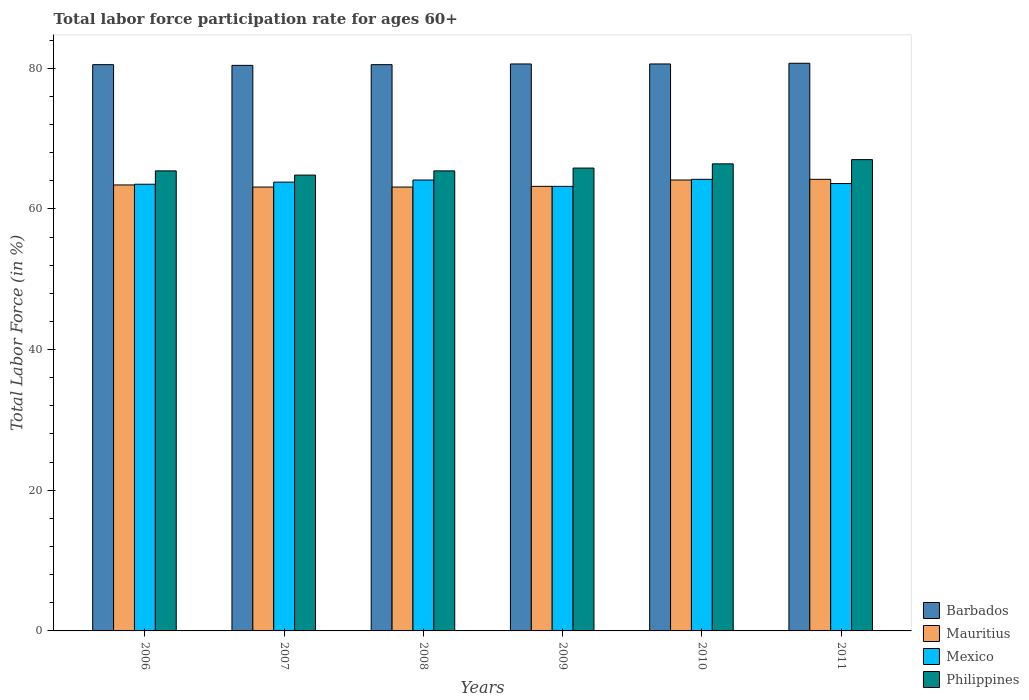How many different coloured bars are there?
Your answer should be very brief. 4. Are the number of bars per tick equal to the number of legend labels?
Your response must be concise. Yes. How many bars are there on the 4th tick from the left?
Offer a very short reply. 4. What is the label of the 4th group of bars from the left?
Provide a short and direct response. 2009. What is the labor force participation rate in Barbados in 2011?
Provide a succinct answer. 80.7. Across all years, what is the maximum labor force participation rate in Mauritius?
Provide a succinct answer. 64.2. Across all years, what is the minimum labor force participation rate in Mexico?
Your answer should be compact. 63.2. In which year was the labor force participation rate in Mexico maximum?
Provide a short and direct response. 2010. In which year was the labor force participation rate in Mexico minimum?
Your answer should be compact. 2009. What is the total labor force participation rate in Mexico in the graph?
Provide a succinct answer. 382.4. What is the difference between the labor force participation rate in Mauritius in 2009 and that in 2011?
Keep it short and to the point. -1. What is the difference between the labor force participation rate in Barbados in 2008 and the labor force participation rate in Mexico in 2006?
Provide a succinct answer. 17. What is the average labor force participation rate in Philippines per year?
Your answer should be compact. 65.8. In the year 2007, what is the difference between the labor force participation rate in Mauritius and labor force participation rate in Philippines?
Give a very brief answer. -1.7. What is the ratio of the labor force participation rate in Mauritius in 2008 to that in 2010?
Your response must be concise. 0.98. Is the difference between the labor force participation rate in Mauritius in 2006 and 2010 greater than the difference between the labor force participation rate in Philippines in 2006 and 2010?
Make the answer very short. Yes. What is the difference between the highest and the second highest labor force participation rate in Mauritius?
Keep it short and to the point. 0.1. What is the difference between the highest and the lowest labor force participation rate in Mexico?
Offer a terse response. 1. In how many years, is the labor force participation rate in Philippines greater than the average labor force participation rate in Philippines taken over all years?
Your answer should be compact. 3. What does the 4th bar from the right in 2010 represents?
Provide a short and direct response. Barbados. Is it the case that in every year, the sum of the labor force participation rate in Philippines and labor force participation rate in Barbados is greater than the labor force participation rate in Mauritius?
Keep it short and to the point. Yes. How many bars are there?
Offer a terse response. 24. What is the difference between two consecutive major ticks on the Y-axis?
Offer a very short reply. 20. Does the graph contain grids?
Your answer should be very brief. No. What is the title of the graph?
Offer a terse response. Total labor force participation rate for ages 60+. Does "Luxembourg" appear as one of the legend labels in the graph?
Ensure brevity in your answer.  No. What is the Total Labor Force (in %) of Barbados in 2006?
Offer a very short reply. 80.5. What is the Total Labor Force (in %) in Mauritius in 2006?
Ensure brevity in your answer.  63.4. What is the Total Labor Force (in %) of Mexico in 2006?
Keep it short and to the point. 63.5. What is the Total Labor Force (in %) in Philippines in 2006?
Ensure brevity in your answer.  65.4. What is the Total Labor Force (in %) in Barbados in 2007?
Your answer should be compact. 80.4. What is the Total Labor Force (in %) in Mauritius in 2007?
Ensure brevity in your answer.  63.1. What is the Total Labor Force (in %) in Mexico in 2007?
Keep it short and to the point. 63.8. What is the Total Labor Force (in %) in Philippines in 2007?
Your answer should be very brief. 64.8. What is the Total Labor Force (in %) in Barbados in 2008?
Your answer should be very brief. 80.5. What is the Total Labor Force (in %) in Mauritius in 2008?
Provide a short and direct response. 63.1. What is the Total Labor Force (in %) in Mexico in 2008?
Your response must be concise. 64.1. What is the Total Labor Force (in %) in Philippines in 2008?
Make the answer very short. 65.4. What is the Total Labor Force (in %) of Barbados in 2009?
Provide a short and direct response. 80.6. What is the Total Labor Force (in %) in Mauritius in 2009?
Make the answer very short. 63.2. What is the Total Labor Force (in %) in Mexico in 2009?
Your answer should be compact. 63.2. What is the Total Labor Force (in %) in Philippines in 2009?
Keep it short and to the point. 65.8. What is the Total Labor Force (in %) in Barbados in 2010?
Your answer should be very brief. 80.6. What is the Total Labor Force (in %) in Mauritius in 2010?
Offer a terse response. 64.1. What is the Total Labor Force (in %) in Mexico in 2010?
Provide a succinct answer. 64.2. What is the Total Labor Force (in %) in Philippines in 2010?
Offer a terse response. 66.4. What is the Total Labor Force (in %) in Barbados in 2011?
Provide a succinct answer. 80.7. What is the Total Labor Force (in %) in Mauritius in 2011?
Your answer should be compact. 64.2. What is the Total Labor Force (in %) of Mexico in 2011?
Provide a succinct answer. 63.6. Across all years, what is the maximum Total Labor Force (in %) of Barbados?
Your response must be concise. 80.7. Across all years, what is the maximum Total Labor Force (in %) of Mauritius?
Your response must be concise. 64.2. Across all years, what is the maximum Total Labor Force (in %) of Mexico?
Your answer should be compact. 64.2. Across all years, what is the maximum Total Labor Force (in %) in Philippines?
Offer a terse response. 67. Across all years, what is the minimum Total Labor Force (in %) of Barbados?
Offer a very short reply. 80.4. Across all years, what is the minimum Total Labor Force (in %) of Mauritius?
Your answer should be very brief. 63.1. Across all years, what is the minimum Total Labor Force (in %) of Mexico?
Offer a very short reply. 63.2. Across all years, what is the minimum Total Labor Force (in %) in Philippines?
Give a very brief answer. 64.8. What is the total Total Labor Force (in %) in Barbados in the graph?
Give a very brief answer. 483.3. What is the total Total Labor Force (in %) of Mauritius in the graph?
Keep it short and to the point. 381.1. What is the total Total Labor Force (in %) of Mexico in the graph?
Offer a terse response. 382.4. What is the total Total Labor Force (in %) in Philippines in the graph?
Provide a short and direct response. 394.8. What is the difference between the Total Labor Force (in %) in Mexico in 2006 and that in 2007?
Your response must be concise. -0.3. What is the difference between the Total Labor Force (in %) of Philippines in 2006 and that in 2007?
Give a very brief answer. 0.6. What is the difference between the Total Labor Force (in %) of Barbados in 2006 and that in 2008?
Your answer should be very brief. 0. What is the difference between the Total Labor Force (in %) of Mauritius in 2006 and that in 2008?
Your answer should be very brief. 0.3. What is the difference between the Total Labor Force (in %) of Philippines in 2006 and that in 2008?
Your answer should be very brief. 0. What is the difference between the Total Labor Force (in %) in Barbados in 2006 and that in 2009?
Give a very brief answer. -0.1. What is the difference between the Total Labor Force (in %) of Mauritius in 2006 and that in 2009?
Offer a very short reply. 0.2. What is the difference between the Total Labor Force (in %) in Mauritius in 2006 and that in 2010?
Provide a succinct answer. -0.7. What is the difference between the Total Labor Force (in %) of Mexico in 2006 and that in 2010?
Keep it short and to the point. -0.7. What is the difference between the Total Labor Force (in %) of Philippines in 2006 and that in 2010?
Keep it short and to the point. -1. What is the difference between the Total Labor Force (in %) in Barbados in 2006 and that in 2011?
Offer a very short reply. -0.2. What is the difference between the Total Labor Force (in %) of Mauritius in 2006 and that in 2011?
Provide a short and direct response. -0.8. What is the difference between the Total Labor Force (in %) of Philippines in 2006 and that in 2011?
Your response must be concise. -1.6. What is the difference between the Total Labor Force (in %) in Barbados in 2007 and that in 2008?
Provide a succinct answer. -0.1. What is the difference between the Total Labor Force (in %) in Philippines in 2007 and that in 2008?
Make the answer very short. -0.6. What is the difference between the Total Labor Force (in %) of Mexico in 2007 and that in 2009?
Provide a succinct answer. 0.6. What is the difference between the Total Labor Force (in %) in Barbados in 2007 and that in 2010?
Ensure brevity in your answer.  -0.2. What is the difference between the Total Labor Force (in %) in Mexico in 2007 and that in 2010?
Offer a very short reply. -0.4. What is the difference between the Total Labor Force (in %) of Philippines in 2007 and that in 2010?
Keep it short and to the point. -1.6. What is the difference between the Total Labor Force (in %) of Mauritius in 2007 and that in 2011?
Your answer should be compact. -1.1. What is the difference between the Total Labor Force (in %) of Philippines in 2007 and that in 2011?
Offer a terse response. -2.2. What is the difference between the Total Labor Force (in %) of Mexico in 2008 and that in 2009?
Keep it short and to the point. 0.9. What is the difference between the Total Labor Force (in %) of Philippines in 2008 and that in 2009?
Provide a succinct answer. -0.4. What is the difference between the Total Labor Force (in %) in Barbados in 2008 and that in 2010?
Your answer should be compact. -0.1. What is the difference between the Total Labor Force (in %) of Mauritius in 2008 and that in 2010?
Keep it short and to the point. -1. What is the difference between the Total Labor Force (in %) of Mexico in 2008 and that in 2010?
Keep it short and to the point. -0.1. What is the difference between the Total Labor Force (in %) of Philippines in 2008 and that in 2010?
Ensure brevity in your answer.  -1. What is the difference between the Total Labor Force (in %) in Mexico in 2008 and that in 2011?
Your answer should be compact. 0.5. What is the difference between the Total Labor Force (in %) of Mauritius in 2009 and that in 2010?
Give a very brief answer. -0.9. What is the difference between the Total Labor Force (in %) of Mexico in 2009 and that in 2010?
Your answer should be compact. -1. What is the difference between the Total Labor Force (in %) of Mexico in 2009 and that in 2011?
Your answer should be very brief. -0.4. What is the difference between the Total Labor Force (in %) in Philippines in 2009 and that in 2011?
Your answer should be compact. -1.2. What is the difference between the Total Labor Force (in %) of Mauritius in 2010 and that in 2011?
Your answer should be compact. -0.1. What is the difference between the Total Labor Force (in %) of Mexico in 2010 and that in 2011?
Give a very brief answer. 0.6. What is the difference between the Total Labor Force (in %) of Philippines in 2010 and that in 2011?
Make the answer very short. -0.6. What is the difference between the Total Labor Force (in %) of Barbados in 2006 and the Total Labor Force (in %) of Philippines in 2007?
Make the answer very short. 15.7. What is the difference between the Total Labor Force (in %) of Mauritius in 2006 and the Total Labor Force (in %) of Philippines in 2008?
Give a very brief answer. -2. What is the difference between the Total Labor Force (in %) in Mexico in 2006 and the Total Labor Force (in %) in Philippines in 2008?
Offer a terse response. -1.9. What is the difference between the Total Labor Force (in %) of Barbados in 2006 and the Total Labor Force (in %) of Mauritius in 2009?
Provide a succinct answer. 17.3. What is the difference between the Total Labor Force (in %) in Mauritius in 2006 and the Total Labor Force (in %) in Philippines in 2009?
Ensure brevity in your answer.  -2.4. What is the difference between the Total Labor Force (in %) of Mexico in 2006 and the Total Labor Force (in %) of Philippines in 2009?
Keep it short and to the point. -2.3. What is the difference between the Total Labor Force (in %) in Barbados in 2006 and the Total Labor Force (in %) in Mauritius in 2010?
Your answer should be very brief. 16.4. What is the difference between the Total Labor Force (in %) of Barbados in 2006 and the Total Labor Force (in %) of Mexico in 2010?
Give a very brief answer. 16.3. What is the difference between the Total Labor Force (in %) of Barbados in 2006 and the Total Labor Force (in %) of Philippines in 2010?
Ensure brevity in your answer.  14.1. What is the difference between the Total Labor Force (in %) of Mauritius in 2006 and the Total Labor Force (in %) of Philippines in 2010?
Ensure brevity in your answer.  -3. What is the difference between the Total Labor Force (in %) of Barbados in 2006 and the Total Labor Force (in %) of Mexico in 2011?
Keep it short and to the point. 16.9. What is the difference between the Total Labor Force (in %) in Mauritius in 2006 and the Total Labor Force (in %) in Philippines in 2011?
Your answer should be very brief. -3.6. What is the difference between the Total Labor Force (in %) of Barbados in 2007 and the Total Labor Force (in %) of Mauritius in 2008?
Offer a terse response. 17.3. What is the difference between the Total Labor Force (in %) of Barbados in 2007 and the Total Labor Force (in %) of Mexico in 2008?
Provide a succinct answer. 16.3. What is the difference between the Total Labor Force (in %) in Mauritius in 2007 and the Total Labor Force (in %) in Mexico in 2008?
Give a very brief answer. -1. What is the difference between the Total Labor Force (in %) in Mauritius in 2007 and the Total Labor Force (in %) in Philippines in 2008?
Provide a short and direct response. -2.3. What is the difference between the Total Labor Force (in %) of Barbados in 2007 and the Total Labor Force (in %) of Philippines in 2009?
Offer a very short reply. 14.6. What is the difference between the Total Labor Force (in %) in Mauritius in 2007 and the Total Labor Force (in %) in Philippines in 2009?
Ensure brevity in your answer.  -2.7. What is the difference between the Total Labor Force (in %) in Barbados in 2007 and the Total Labor Force (in %) in Mauritius in 2010?
Provide a succinct answer. 16.3. What is the difference between the Total Labor Force (in %) in Barbados in 2007 and the Total Labor Force (in %) in Mexico in 2010?
Give a very brief answer. 16.2. What is the difference between the Total Labor Force (in %) of Mauritius in 2007 and the Total Labor Force (in %) of Mexico in 2010?
Offer a very short reply. -1.1. What is the difference between the Total Labor Force (in %) in Mauritius in 2007 and the Total Labor Force (in %) in Philippines in 2010?
Give a very brief answer. -3.3. What is the difference between the Total Labor Force (in %) in Mexico in 2007 and the Total Labor Force (in %) in Philippines in 2010?
Give a very brief answer. -2.6. What is the difference between the Total Labor Force (in %) of Barbados in 2007 and the Total Labor Force (in %) of Mauritius in 2011?
Provide a succinct answer. 16.2. What is the difference between the Total Labor Force (in %) in Barbados in 2007 and the Total Labor Force (in %) in Mexico in 2011?
Give a very brief answer. 16.8. What is the difference between the Total Labor Force (in %) of Barbados in 2007 and the Total Labor Force (in %) of Philippines in 2011?
Give a very brief answer. 13.4. What is the difference between the Total Labor Force (in %) in Mauritius in 2007 and the Total Labor Force (in %) in Mexico in 2011?
Offer a very short reply. -0.5. What is the difference between the Total Labor Force (in %) in Mauritius in 2007 and the Total Labor Force (in %) in Philippines in 2011?
Ensure brevity in your answer.  -3.9. What is the difference between the Total Labor Force (in %) of Mauritius in 2008 and the Total Labor Force (in %) of Philippines in 2009?
Provide a short and direct response. -2.7. What is the difference between the Total Labor Force (in %) of Barbados in 2008 and the Total Labor Force (in %) of Mexico in 2010?
Your answer should be compact. 16.3. What is the difference between the Total Labor Force (in %) of Mauritius in 2008 and the Total Labor Force (in %) of Philippines in 2010?
Keep it short and to the point. -3.3. What is the difference between the Total Labor Force (in %) of Mexico in 2008 and the Total Labor Force (in %) of Philippines in 2010?
Keep it short and to the point. -2.3. What is the difference between the Total Labor Force (in %) in Barbados in 2008 and the Total Labor Force (in %) in Mauritius in 2011?
Keep it short and to the point. 16.3. What is the difference between the Total Labor Force (in %) in Barbados in 2008 and the Total Labor Force (in %) in Mexico in 2011?
Provide a short and direct response. 16.9. What is the difference between the Total Labor Force (in %) in Mauritius in 2008 and the Total Labor Force (in %) in Mexico in 2011?
Give a very brief answer. -0.5. What is the difference between the Total Labor Force (in %) in Mauritius in 2008 and the Total Labor Force (in %) in Philippines in 2011?
Your response must be concise. -3.9. What is the difference between the Total Labor Force (in %) in Barbados in 2009 and the Total Labor Force (in %) in Mexico in 2010?
Your response must be concise. 16.4. What is the difference between the Total Labor Force (in %) in Mauritius in 2009 and the Total Labor Force (in %) in Mexico in 2010?
Make the answer very short. -1. What is the difference between the Total Labor Force (in %) in Mauritius in 2009 and the Total Labor Force (in %) in Philippines in 2010?
Your answer should be very brief. -3.2. What is the difference between the Total Labor Force (in %) in Mexico in 2009 and the Total Labor Force (in %) in Philippines in 2010?
Your answer should be compact. -3.2. What is the difference between the Total Labor Force (in %) in Barbados in 2009 and the Total Labor Force (in %) in Mexico in 2011?
Your answer should be compact. 17. What is the difference between the Total Labor Force (in %) in Barbados in 2010 and the Total Labor Force (in %) in Mauritius in 2011?
Offer a very short reply. 16.4. What is the difference between the Total Labor Force (in %) of Barbados in 2010 and the Total Labor Force (in %) of Mexico in 2011?
Provide a short and direct response. 17. What is the difference between the Total Labor Force (in %) of Barbados in 2010 and the Total Labor Force (in %) of Philippines in 2011?
Provide a short and direct response. 13.6. What is the difference between the Total Labor Force (in %) in Mauritius in 2010 and the Total Labor Force (in %) in Mexico in 2011?
Keep it short and to the point. 0.5. What is the average Total Labor Force (in %) in Barbados per year?
Provide a short and direct response. 80.55. What is the average Total Labor Force (in %) in Mauritius per year?
Ensure brevity in your answer.  63.52. What is the average Total Labor Force (in %) in Mexico per year?
Make the answer very short. 63.73. What is the average Total Labor Force (in %) of Philippines per year?
Ensure brevity in your answer.  65.8. In the year 2006, what is the difference between the Total Labor Force (in %) in Barbados and Total Labor Force (in %) in Mauritius?
Keep it short and to the point. 17.1. In the year 2006, what is the difference between the Total Labor Force (in %) in Barbados and Total Labor Force (in %) in Mexico?
Your response must be concise. 17. In the year 2006, what is the difference between the Total Labor Force (in %) in Mauritius and Total Labor Force (in %) in Mexico?
Give a very brief answer. -0.1. In the year 2007, what is the difference between the Total Labor Force (in %) in Barbados and Total Labor Force (in %) in Mexico?
Offer a very short reply. 16.6. In the year 2007, what is the difference between the Total Labor Force (in %) in Mauritius and Total Labor Force (in %) in Mexico?
Provide a short and direct response. -0.7. In the year 2007, what is the difference between the Total Labor Force (in %) in Mauritius and Total Labor Force (in %) in Philippines?
Your response must be concise. -1.7. In the year 2007, what is the difference between the Total Labor Force (in %) of Mexico and Total Labor Force (in %) of Philippines?
Give a very brief answer. -1. In the year 2009, what is the difference between the Total Labor Force (in %) in Barbados and Total Labor Force (in %) in Mexico?
Offer a very short reply. 17.4. In the year 2009, what is the difference between the Total Labor Force (in %) in Barbados and Total Labor Force (in %) in Philippines?
Give a very brief answer. 14.8. In the year 2009, what is the difference between the Total Labor Force (in %) in Mauritius and Total Labor Force (in %) in Mexico?
Make the answer very short. 0. In the year 2009, what is the difference between the Total Labor Force (in %) in Mauritius and Total Labor Force (in %) in Philippines?
Offer a very short reply. -2.6. In the year 2010, what is the difference between the Total Labor Force (in %) of Barbados and Total Labor Force (in %) of Philippines?
Provide a short and direct response. 14.2. In the year 2010, what is the difference between the Total Labor Force (in %) of Mexico and Total Labor Force (in %) of Philippines?
Keep it short and to the point. -2.2. In the year 2011, what is the difference between the Total Labor Force (in %) in Barbados and Total Labor Force (in %) in Mauritius?
Ensure brevity in your answer.  16.5. In the year 2011, what is the difference between the Total Labor Force (in %) of Mauritius and Total Labor Force (in %) of Mexico?
Provide a succinct answer. 0.6. In the year 2011, what is the difference between the Total Labor Force (in %) of Mexico and Total Labor Force (in %) of Philippines?
Offer a terse response. -3.4. What is the ratio of the Total Labor Force (in %) in Barbados in 2006 to that in 2007?
Give a very brief answer. 1. What is the ratio of the Total Labor Force (in %) in Mexico in 2006 to that in 2007?
Provide a succinct answer. 1. What is the ratio of the Total Labor Force (in %) of Philippines in 2006 to that in 2007?
Offer a terse response. 1.01. What is the ratio of the Total Labor Force (in %) of Mexico in 2006 to that in 2008?
Offer a very short reply. 0.99. What is the ratio of the Total Labor Force (in %) in Philippines in 2006 to that in 2009?
Your response must be concise. 0.99. What is the ratio of the Total Labor Force (in %) in Philippines in 2006 to that in 2010?
Ensure brevity in your answer.  0.98. What is the ratio of the Total Labor Force (in %) in Barbados in 2006 to that in 2011?
Provide a succinct answer. 1. What is the ratio of the Total Labor Force (in %) of Mauritius in 2006 to that in 2011?
Your response must be concise. 0.99. What is the ratio of the Total Labor Force (in %) of Philippines in 2006 to that in 2011?
Make the answer very short. 0.98. What is the ratio of the Total Labor Force (in %) in Mauritius in 2007 to that in 2008?
Provide a short and direct response. 1. What is the ratio of the Total Labor Force (in %) of Barbados in 2007 to that in 2009?
Ensure brevity in your answer.  1. What is the ratio of the Total Labor Force (in %) in Mauritius in 2007 to that in 2009?
Provide a short and direct response. 1. What is the ratio of the Total Labor Force (in %) in Mexico in 2007 to that in 2009?
Offer a very short reply. 1.01. What is the ratio of the Total Labor Force (in %) of Barbados in 2007 to that in 2010?
Provide a short and direct response. 1. What is the ratio of the Total Labor Force (in %) in Mauritius in 2007 to that in 2010?
Offer a very short reply. 0.98. What is the ratio of the Total Labor Force (in %) of Mexico in 2007 to that in 2010?
Keep it short and to the point. 0.99. What is the ratio of the Total Labor Force (in %) of Philippines in 2007 to that in 2010?
Your answer should be very brief. 0.98. What is the ratio of the Total Labor Force (in %) in Mauritius in 2007 to that in 2011?
Ensure brevity in your answer.  0.98. What is the ratio of the Total Labor Force (in %) of Philippines in 2007 to that in 2011?
Offer a terse response. 0.97. What is the ratio of the Total Labor Force (in %) in Mexico in 2008 to that in 2009?
Offer a very short reply. 1.01. What is the ratio of the Total Labor Force (in %) in Mauritius in 2008 to that in 2010?
Make the answer very short. 0.98. What is the ratio of the Total Labor Force (in %) of Philippines in 2008 to that in 2010?
Offer a very short reply. 0.98. What is the ratio of the Total Labor Force (in %) of Barbados in 2008 to that in 2011?
Your answer should be very brief. 1. What is the ratio of the Total Labor Force (in %) in Mauritius in 2008 to that in 2011?
Ensure brevity in your answer.  0.98. What is the ratio of the Total Labor Force (in %) of Mexico in 2008 to that in 2011?
Offer a very short reply. 1.01. What is the ratio of the Total Labor Force (in %) in Philippines in 2008 to that in 2011?
Your response must be concise. 0.98. What is the ratio of the Total Labor Force (in %) in Mexico in 2009 to that in 2010?
Your answer should be compact. 0.98. What is the ratio of the Total Labor Force (in %) in Barbados in 2009 to that in 2011?
Make the answer very short. 1. What is the ratio of the Total Labor Force (in %) of Mauritius in 2009 to that in 2011?
Give a very brief answer. 0.98. What is the ratio of the Total Labor Force (in %) in Philippines in 2009 to that in 2011?
Your answer should be compact. 0.98. What is the ratio of the Total Labor Force (in %) of Barbados in 2010 to that in 2011?
Offer a very short reply. 1. What is the ratio of the Total Labor Force (in %) of Mauritius in 2010 to that in 2011?
Provide a succinct answer. 1. What is the ratio of the Total Labor Force (in %) in Mexico in 2010 to that in 2011?
Give a very brief answer. 1.01. What is the ratio of the Total Labor Force (in %) in Philippines in 2010 to that in 2011?
Give a very brief answer. 0.99. What is the difference between the highest and the second highest Total Labor Force (in %) of Mauritius?
Make the answer very short. 0.1. What is the difference between the highest and the second highest Total Labor Force (in %) in Mexico?
Your answer should be very brief. 0.1. What is the difference between the highest and the second highest Total Labor Force (in %) of Philippines?
Give a very brief answer. 0.6. What is the difference between the highest and the lowest Total Labor Force (in %) in Barbados?
Provide a succinct answer. 0.3. What is the difference between the highest and the lowest Total Labor Force (in %) of Mauritius?
Provide a succinct answer. 1.1. What is the difference between the highest and the lowest Total Labor Force (in %) of Mexico?
Offer a terse response. 1. 